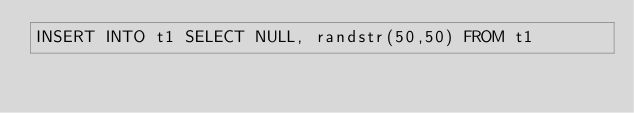<code> <loc_0><loc_0><loc_500><loc_500><_SQL_>INSERT INTO t1 SELECT NULL, randstr(50,50) FROM t1</code> 